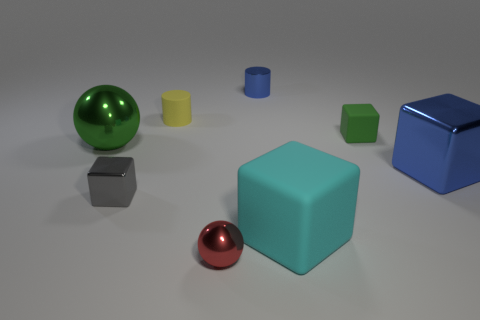What is the size of the block that is the same color as the small shiny cylinder?
Provide a short and direct response. Large. Are there any big matte objects that have the same color as the large matte cube?
Provide a succinct answer. No. There is a green thing that is the same material as the small ball; what size is it?
Provide a succinct answer. Large. What is the shape of the big metallic thing right of the big block on the left side of the metal block that is right of the small gray metal thing?
Make the answer very short. Cube. The other metallic thing that is the same shape as the small yellow object is what size?
Offer a terse response. Small. What size is the thing that is both right of the red metal sphere and left of the big matte object?
Provide a succinct answer. Small. There is a object that is the same color as the large shiny block; what is its shape?
Provide a succinct answer. Cylinder. The tiny shiny ball is what color?
Keep it short and to the point. Red. There is a green thing that is behind the big metallic ball; what size is it?
Make the answer very short. Small. There is a small block behind the big metallic thing left of the blue cylinder; what number of large metallic things are on the left side of it?
Your response must be concise. 1. 